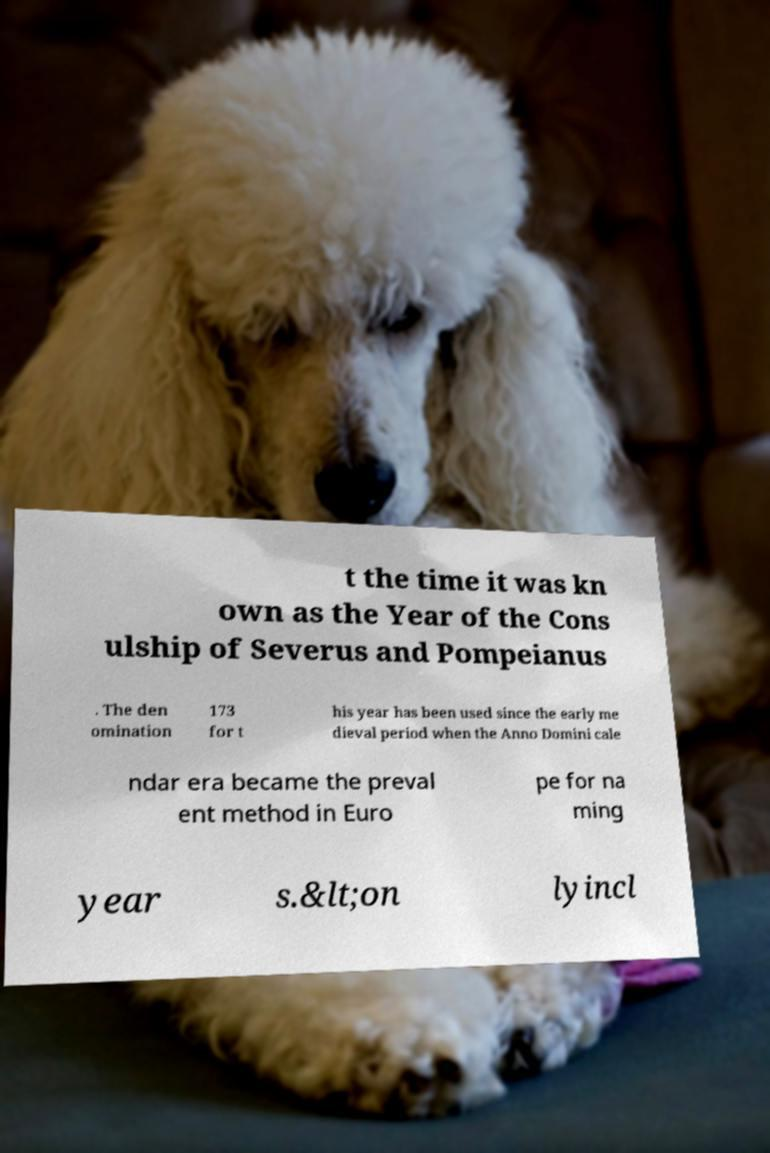Please read and relay the text visible in this image. What does it say? t the time it was kn own as the Year of the Cons ulship of Severus and Pompeianus . The den omination 173 for t his year has been used since the early me dieval period when the Anno Domini cale ndar era became the preval ent method in Euro pe for na ming year s.&lt;on lyincl 